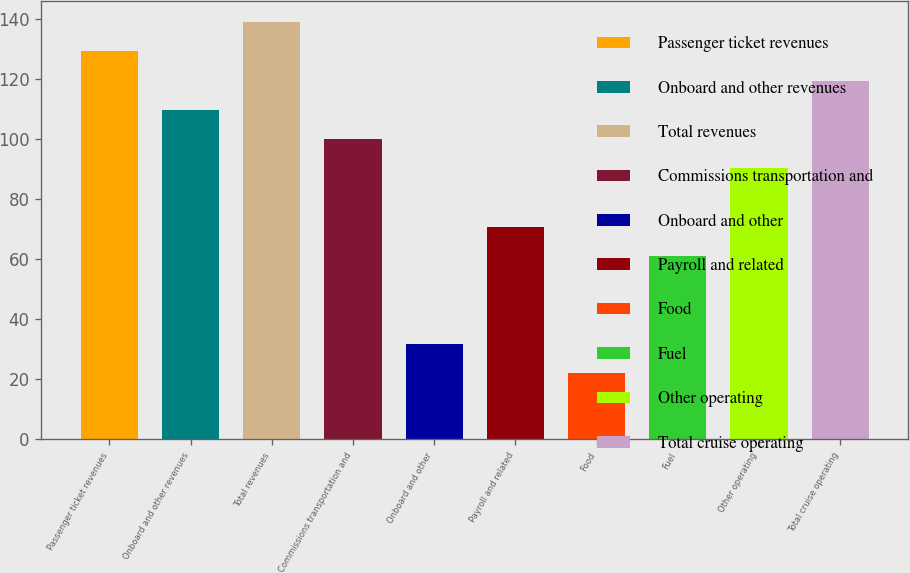Convert chart. <chart><loc_0><loc_0><loc_500><loc_500><bar_chart><fcel>Passenger ticket revenues<fcel>Onboard and other revenues<fcel>Total revenues<fcel>Commissions transportation and<fcel>Onboard and other<fcel>Payroll and related<fcel>Food<fcel>Fuel<fcel>Other operating<fcel>Total cruise operating<nl><fcel>129.19<fcel>109.73<fcel>138.92<fcel>100<fcel>31.89<fcel>70.81<fcel>22.16<fcel>61.08<fcel>90.27<fcel>119.46<nl></chart> 